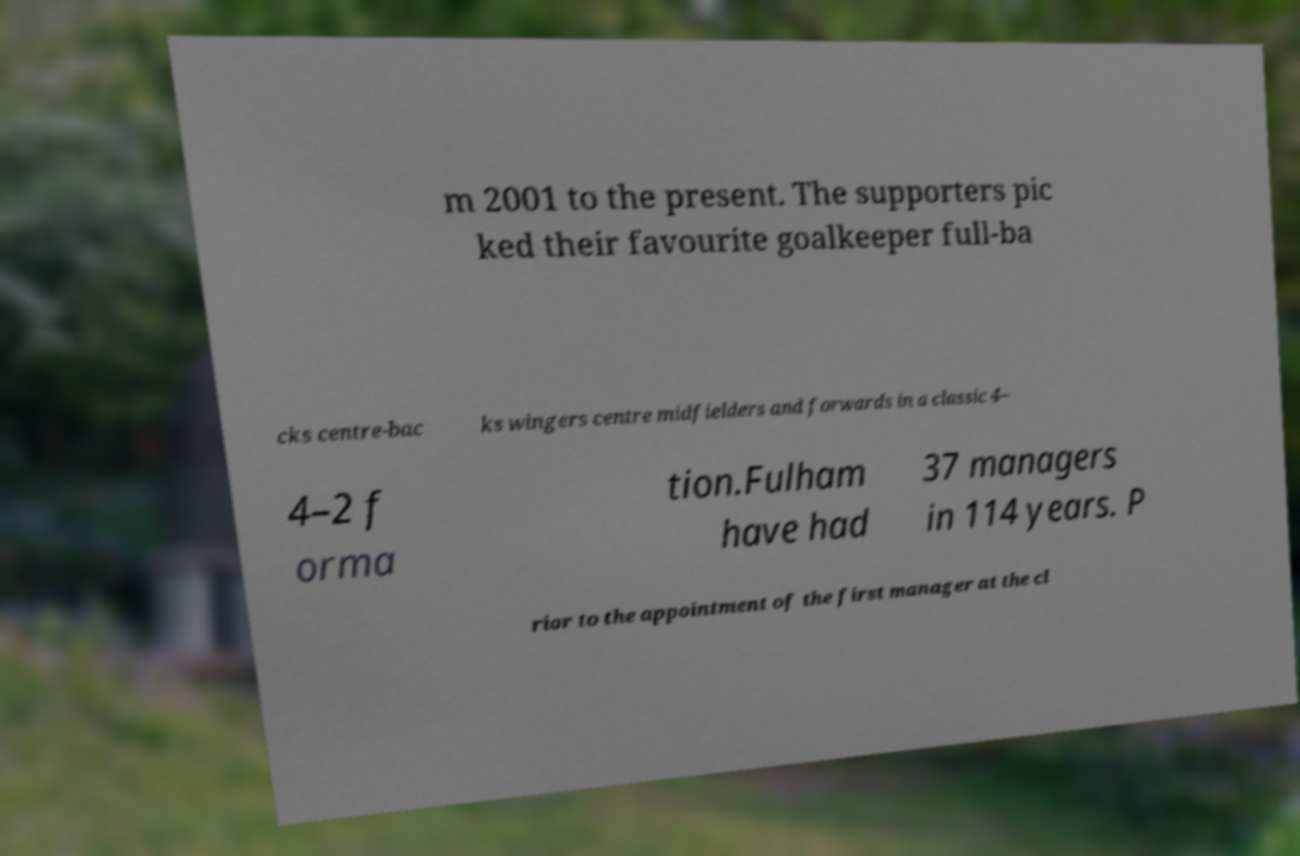Could you assist in decoding the text presented in this image and type it out clearly? m 2001 to the present. The supporters pic ked their favourite goalkeeper full-ba cks centre-bac ks wingers centre midfielders and forwards in a classic 4– 4–2 f orma tion.Fulham have had 37 managers in 114 years. P rior to the appointment of the first manager at the cl 